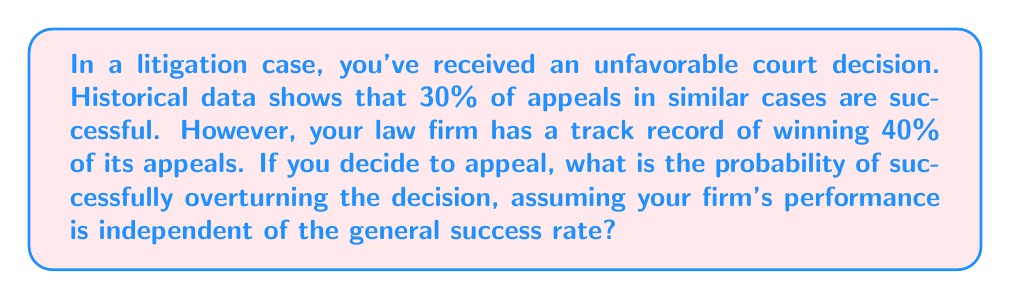Provide a solution to this math problem. Let's approach this step-by-step:

1) Let A be the event of a successful appeal in general, and B be the event of your firm taking the case.

2) We're given:
   P(A) = 0.30 (general success rate)
   P(B) = 1 (your firm is definitely taking the case)
   P(A|B) = 0.40 (your firm's success rate)

3) We want to find P(A|B), which we already know is 0.40. However, let's verify this using Bayes' Theorem to ensure we're not overlooking any dependencies:

   $$P(A|B) = \frac{P(B|A)P(A)}{P(B)}$$

4) We know P(B) = 1 and P(A) = 0.30, but we don't know P(B|A). However, we're told that your firm's performance is independent of the general success rate. This means:

   P(B|A) = P(B) = 1

5) Substituting into Bayes' Theorem:

   $$P(A|B) = \frac{1 \times 0.30}{1} = 0.30$$

6) This result (0.30) doesn't match the given probability of your firm's success (0.40), confirming that your firm's performance is indeed better than the general rate and should be used as the final probability.

Therefore, the probability of successfully appealing the decision is 0.40 or 40%.
Answer: 0.40 